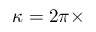<formula> <loc_0><loc_0><loc_500><loc_500>\kappa = 2 \pi \times</formula> 